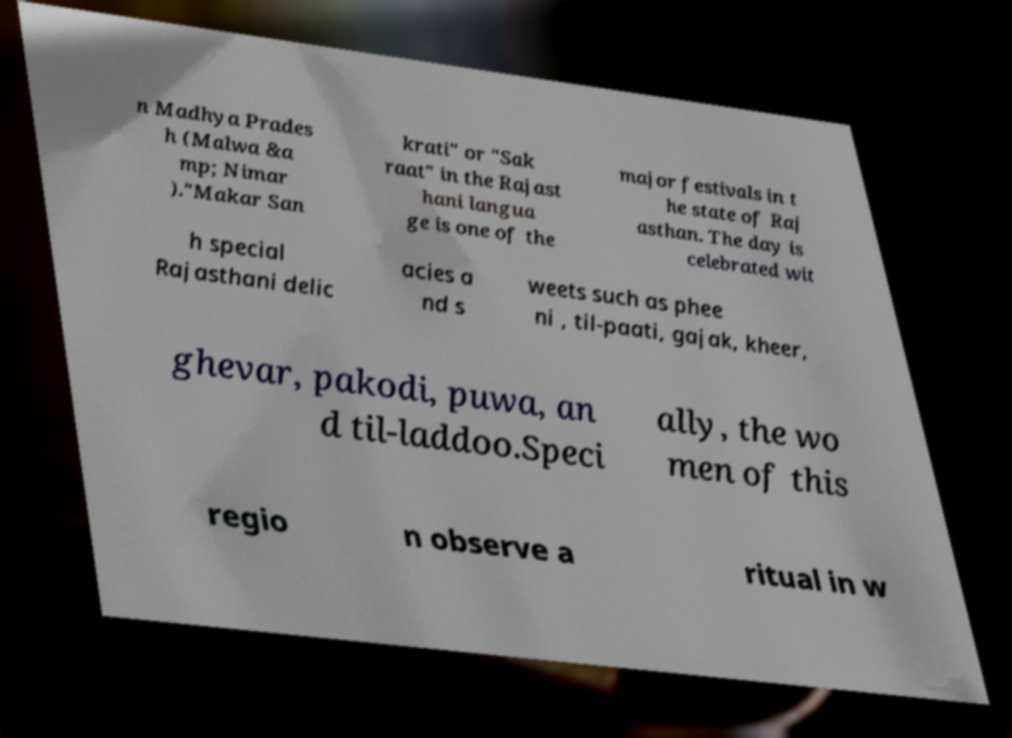Can you read and provide the text displayed in the image?This photo seems to have some interesting text. Can you extract and type it out for me? n Madhya Prades h (Malwa &a mp; Nimar )."Makar San krati" or "Sak raat" in the Rajast hani langua ge is one of the major festivals in t he state of Raj asthan. The day is celebrated wit h special Rajasthani delic acies a nd s weets such as phee ni , til-paati, gajak, kheer, ghevar, pakodi, puwa, an d til-laddoo.Speci ally, the wo men of this regio n observe a ritual in w 